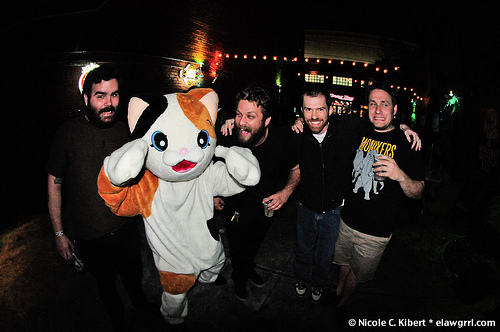<image>
Is the man on the man? No. The man is not positioned on the man. They may be near each other, but the man is not supported by or resting on top of the man. Where is the costume in relation to the person? Is it on the person? No. The costume is not positioned on the person. They may be near each other, but the costume is not supported by or resting on top of the person. Is there a person in the suit? Yes. The person is contained within or inside the suit, showing a containment relationship. Is there a man in front of the man? No. The man is not in front of the man. The spatial positioning shows a different relationship between these objects. Is the cat in front of the floor? No. The cat is not in front of the floor. The spatial positioning shows a different relationship between these objects. 